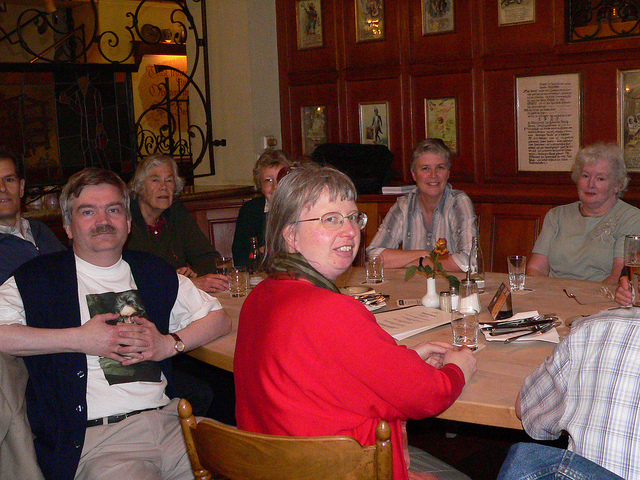<image>What kind of animal is on the wall? There is no animal on the wall. However, if visible it could be a deer, dog, bear or even a human. Red or white wine? There is no wine in the image. However, if there was, it could be white wine. What kind of animal is on the wall? I am not sure what kind of animal is on the wall. It can be either deer, dog, bear or human. Red or white wine? I don't know if the wine is red or white. It can be seen white. 